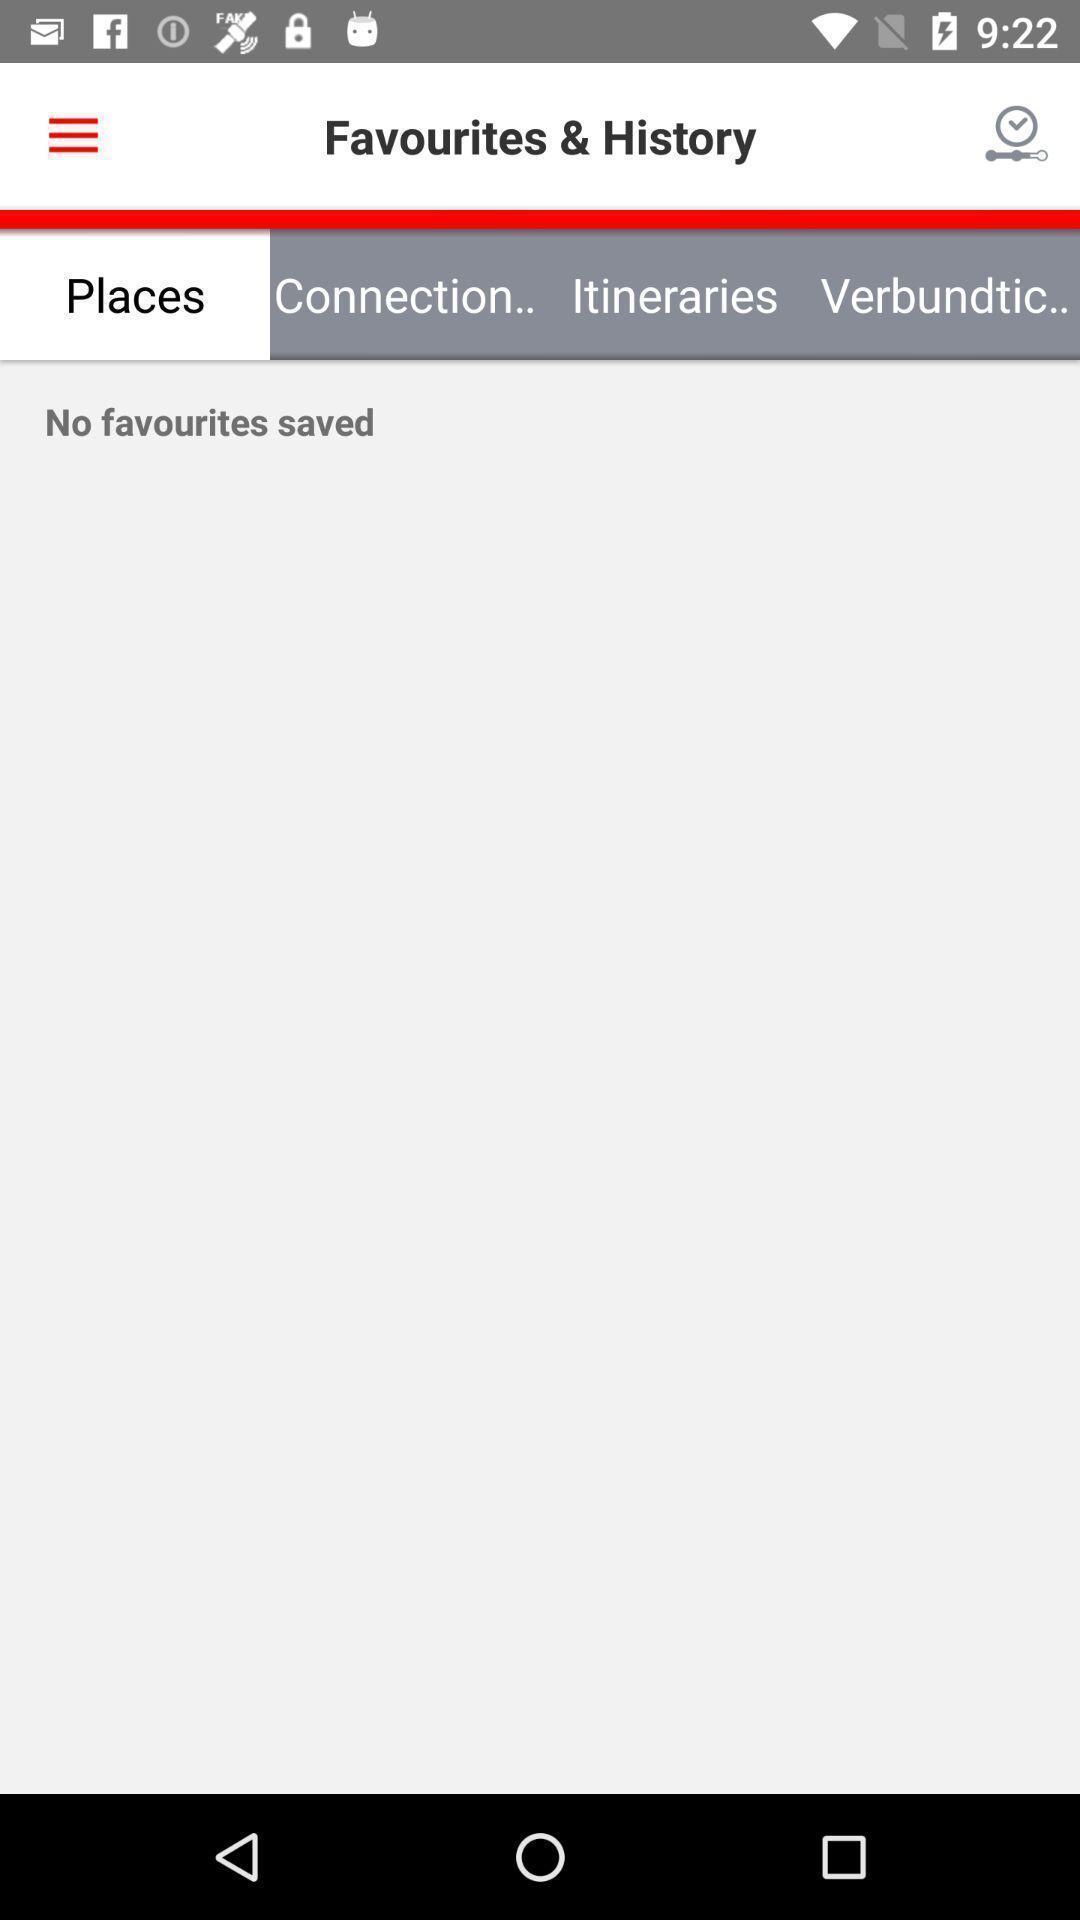What details can you identify in this image? Screen shows favourites history details. 